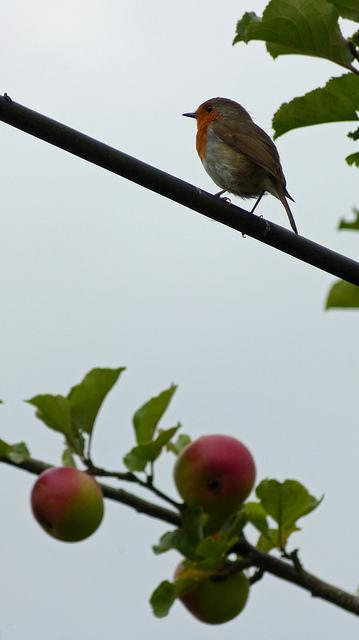How many birds are hanging upside down? Please explain your reasoning. none. The only bird pictured is standing on the branch, right side up. 